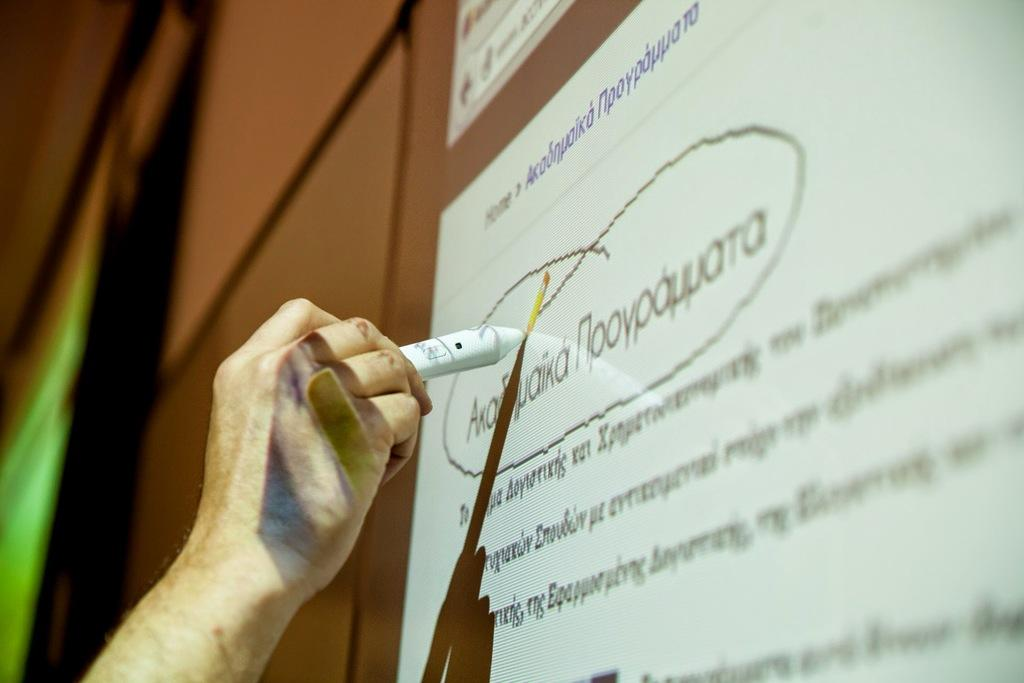What is the main subject of the image? There is a person in the image. What is the person holding in their hand? The person is holding a marker in their hand. What is the person doing with the marker? The person is pointing the marker at a screen. How many fingers does the person hate in the image? There is no indication in the image that the person hates any fingers. 